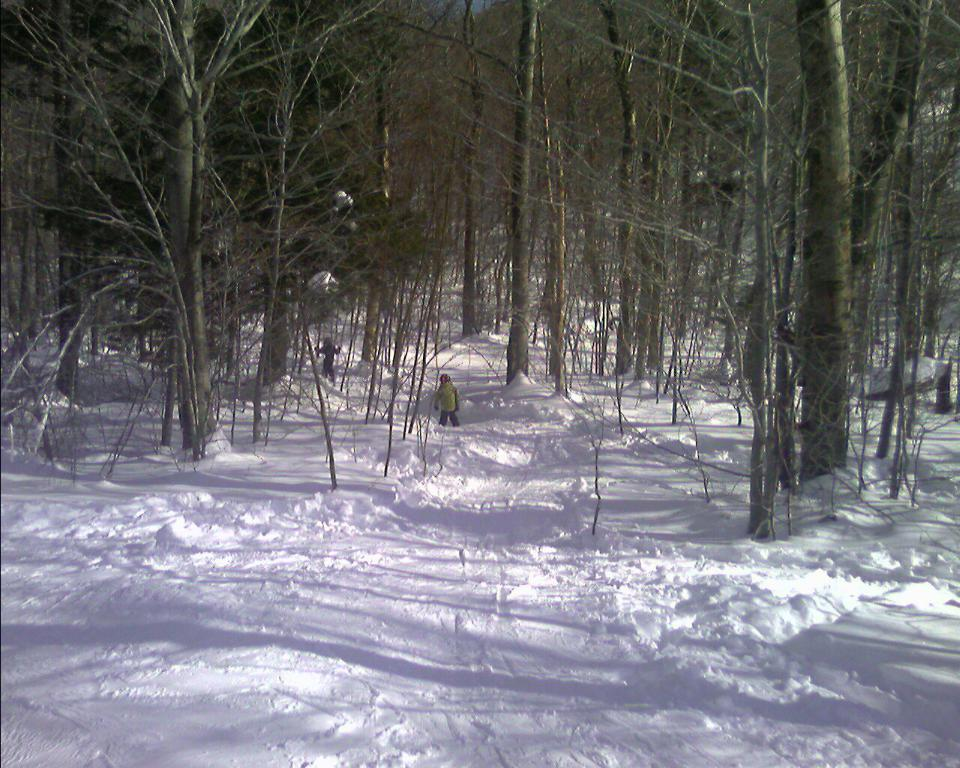What is the main subject of the image? There is a person standing in the image. What is the person wearing? The person is wearing a green jacket. What can be seen in the background of the image? There are dried trees in the background of the image. What is the color and condition of the snow in the image? The snow is visible in the image, and it is white in color. How many sisters does the person in the image have? There is no information about the person's sisters in the image. What caused the snow to fall in the image? The cause of the snowfall is not visible or mentioned in the image. 